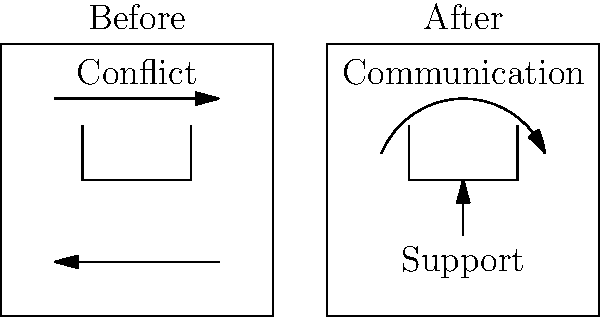Based on the before-and-after visual comparison of family dynamics, what is the primary positive change that has occurred? To answer this question, we need to analyze the visual elements in both the "Before" and "After" scenarios:

1. In the "Before" scenario:
   - We see opposing arrows, indicating conflict
   - Family members are represented as separate, disconnected entities

2. In the "After" scenario:
   - We observe a curved arrow connecting family members, labeled "Communication"
   - There's an upward arrow labeled "Support"
   - Family members are still represented individually but appear more connected

3. Comparing the two scenarios:
   - The conflict has been replaced by communication
   - Support has been introduced as a new element
   - The family appears more unified and connected

4. The primary positive change:
   - While both communication and support are improvements, communication is the overarching change that enables support and resolves conflict

Therefore, the primary positive change depicted in the family dynamics is the introduction of effective communication.
Answer: Improved communication 